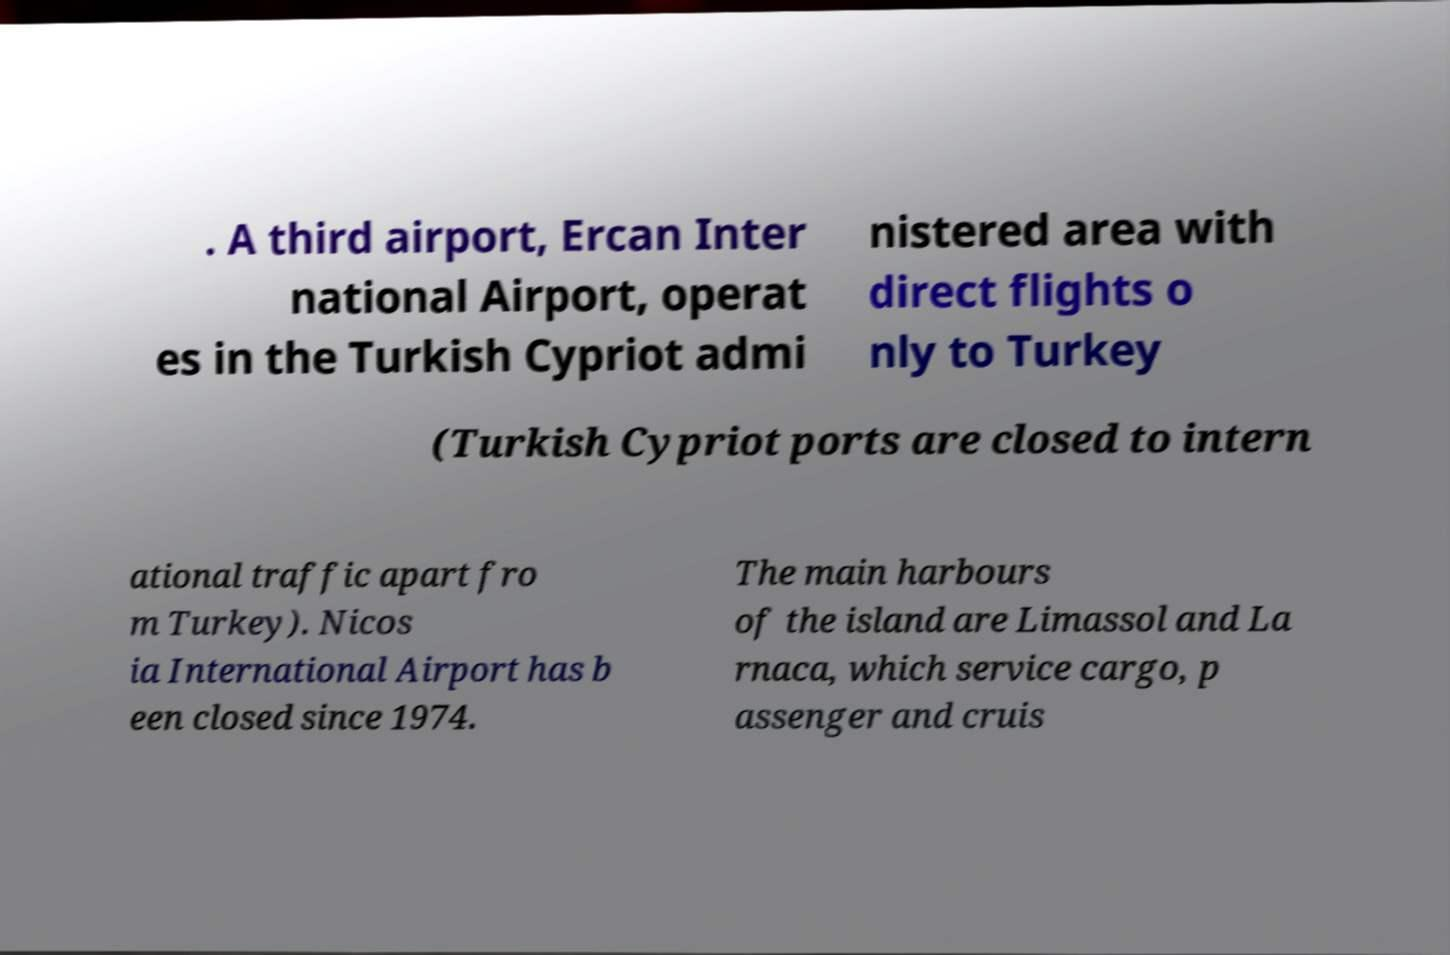I need the written content from this picture converted into text. Can you do that? . A third airport, Ercan Inter national Airport, operat es in the Turkish Cypriot admi nistered area with direct flights o nly to Turkey (Turkish Cypriot ports are closed to intern ational traffic apart fro m Turkey). Nicos ia International Airport has b een closed since 1974. The main harbours of the island are Limassol and La rnaca, which service cargo, p assenger and cruis 